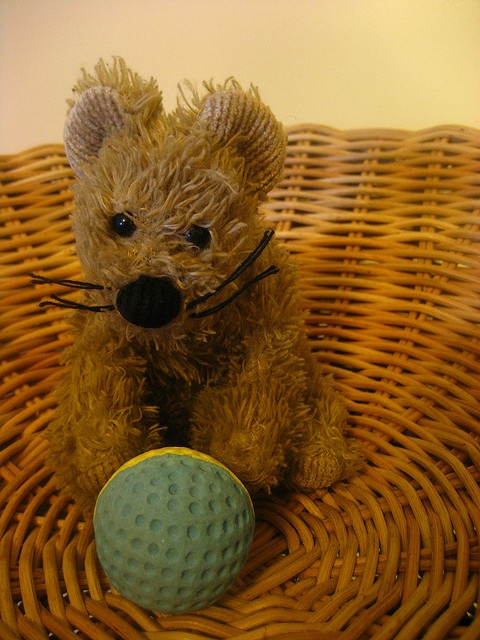Describe the objects in this image and their specific colors. I can see teddy bear in tan, maroon, olive, and black tones and sports ball in tan, darkgreen, black, and maroon tones in this image. 